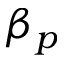Convert formula to latex. <formula><loc_0><loc_0><loc_500><loc_500>\beta _ { p }</formula> 